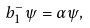Convert formula to latex. <formula><loc_0><loc_0><loc_500><loc_500>b _ { 1 } ^ { - } \psi = \alpha \psi ,</formula> 